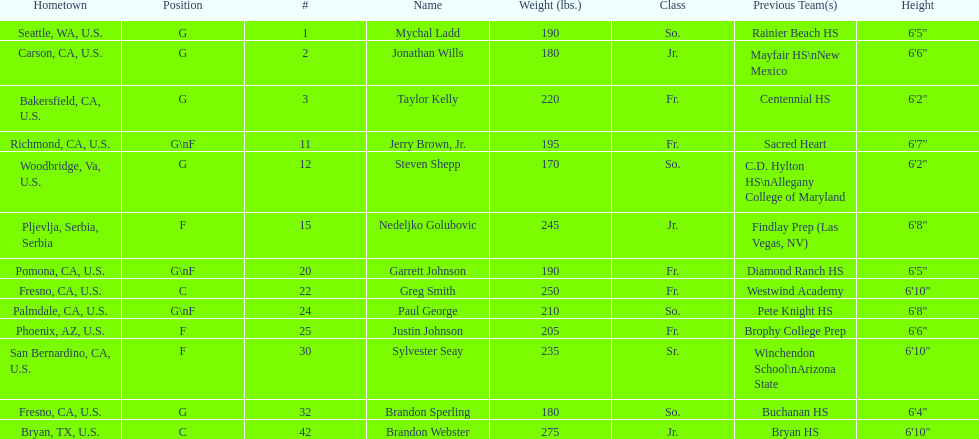Can you give me this table as a dict? {'header': ['Hometown', 'Position', '#', 'Name', 'Weight (lbs.)', 'Class', 'Previous Team(s)', 'Height'], 'rows': [['Seattle, WA, U.S.', 'G', '1', 'Mychal Ladd', '190', 'So.', 'Rainier Beach HS', '6\'5"'], ['Carson, CA, U.S.', 'G', '2', 'Jonathan Wills', '180', 'Jr.', 'Mayfair HS\\nNew Mexico', '6\'6"'], ['Bakersfield, CA, U.S.', 'G', '3', 'Taylor Kelly', '220', 'Fr.', 'Centennial HS', '6\'2"'], ['Richmond, CA, U.S.', 'G\\nF', '11', 'Jerry Brown, Jr.', '195', 'Fr.', 'Sacred Heart', '6\'7"'], ['Woodbridge, Va, U.S.', 'G', '12', 'Steven Shepp', '170', 'So.', 'C.D. Hylton HS\\nAllegany College of Maryland', '6\'2"'], ['Pljevlja, Serbia, Serbia', 'F', '15', 'Nedeljko Golubovic', '245', 'Jr.', 'Findlay Prep (Las Vegas, NV)', '6\'8"'], ['Pomona, CA, U.S.', 'G\\nF', '20', 'Garrett Johnson', '190', 'Fr.', 'Diamond Ranch HS', '6\'5"'], ['Fresno, CA, U.S.', 'C', '22', 'Greg Smith', '250', 'Fr.', 'Westwind Academy', '6\'10"'], ['Palmdale, CA, U.S.', 'G\\nF', '24', 'Paul George', '210', 'So.', 'Pete Knight HS', '6\'8"'], ['Phoenix, AZ, U.S.', 'F', '25', 'Justin Johnson', '205', 'Fr.', 'Brophy College Prep', '6\'6"'], ['San Bernardino, CA, U.S.', 'F', '30', 'Sylvester Seay', '235', 'Sr.', 'Winchendon School\\nArizona State', '6\'10"'], ['Fresno, CA, U.S.', 'G', '32', 'Brandon Sperling', '180', 'So.', 'Buchanan HS', '6\'4"'], ['Bryan, TX, U.S.', 'C', '42', 'Brandon Webster', '275', 'Jr.', 'Bryan HS', '6\'10"']]} Taylor kelly is shorter than 6' 3", which other player is also shorter than 6' 3"? Steven Shepp. 